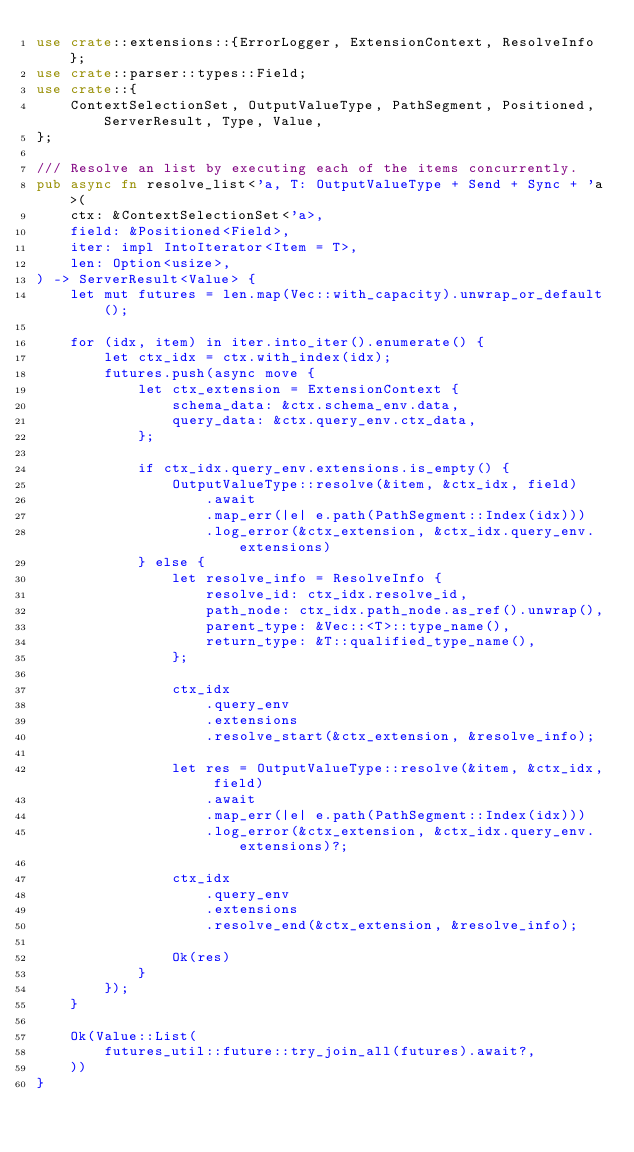<code> <loc_0><loc_0><loc_500><loc_500><_Rust_>use crate::extensions::{ErrorLogger, ExtensionContext, ResolveInfo};
use crate::parser::types::Field;
use crate::{
    ContextSelectionSet, OutputValueType, PathSegment, Positioned, ServerResult, Type, Value,
};

/// Resolve an list by executing each of the items concurrently.
pub async fn resolve_list<'a, T: OutputValueType + Send + Sync + 'a>(
    ctx: &ContextSelectionSet<'a>,
    field: &Positioned<Field>,
    iter: impl IntoIterator<Item = T>,
    len: Option<usize>,
) -> ServerResult<Value> {
    let mut futures = len.map(Vec::with_capacity).unwrap_or_default();

    for (idx, item) in iter.into_iter().enumerate() {
        let ctx_idx = ctx.with_index(idx);
        futures.push(async move {
            let ctx_extension = ExtensionContext {
                schema_data: &ctx.schema_env.data,
                query_data: &ctx.query_env.ctx_data,
            };

            if ctx_idx.query_env.extensions.is_empty() {
                OutputValueType::resolve(&item, &ctx_idx, field)
                    .await
                    .map_err(|e| e.path(PathSegment::Index(idx)))
                    .log_error(&ctx_extension, &ctx_idx.query_env.extensions)
            } else {
                let resolve_info = ResolveInfo {
                    resolve_id: ctx_idx.resolve_id,
                    path_node: ctx_idx.path_node.as_ref().unwrap(),
                    parent_type: &Vec::<T>::type_name(),
                    return_type: &T::qualified_type_name(),
                };

                ctx_idx
                    .query_env
                    .extensions
                    .resolve_start(&ctx_extension, &resolve_info);

                let res = OutputValueType::resolve(&item, &ctx_idx, field)
                    .await
                    .map_err(|e| e.path(PathSegment::Index(idx)))
                    .log_error(&ctx_extension, &ctx_idx.query_env.extensions)?;

                ctx_idx
                    .query_env
                    .extensions
                    .resolve_end(&ctx_extension, &resolve_info);

                Ok(res)
            }
        });
    }

    Ok(Value::List(
        futures_util::future::try_join_all(futures).await?,
    ))
}
</code> 